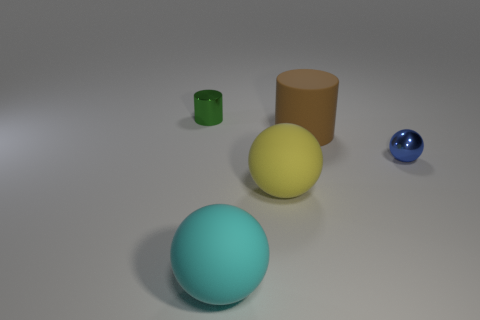What number of other objects are there of the same size as the green cylinder?
Ensure brevity in your answer.  1. What number of things are blue rubber spheres or small things to the left of the matte cylinder?
Give a very brief answer. 1. Is the number of large matte things behind the small green cylinder the same as the number of large cyan spheres?
Your response must be concise. No. What shape is the tiny blue thing that is the same material as the small green thing?
Your response must be concise. Sphere. What number of metallic objects are either yellow spheres or large brown cylinders?
Offer a very short reply. 0. There is a shiny thing that is on the left side of the brown object; what number of yellow rubber spheres are to the left of it?
Keep it short and to the point. 0. How many brown cylinders have the same material as the big yellow sphere?
Your response must be concise. 1. How many big objects are either cyan rubber objects or brown matte cylinders?
Provide a succinct answer. 2. The object that is both on the left side of the large brown matte cylinder and behind the blue shiny ball has what shape?
Offer a very short reply. Cylinder. Does the blue ball have the same material as the small green object?
Your answer should be compact. Yes. 